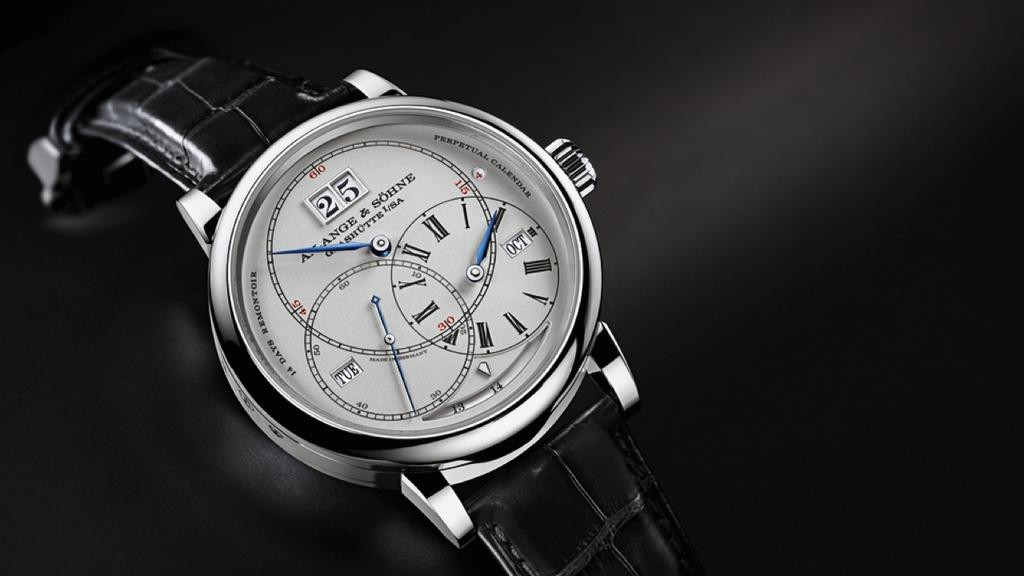Provide a one-sentence caption for the provided image. Black and white A Lange & Sohne watch. 